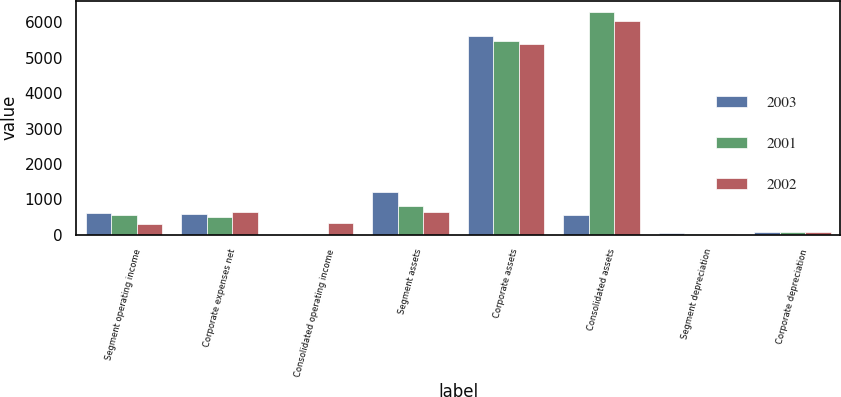<chart> <loc_0><loc_0><loc_500><loc_500><stacked_bar_chart><ecel><fcel>Segment operating income<fcel>Corporate expenses net<fcel>Consolidated operating income<fcel>Segment assets<fcel>Corporate assets<fcel>Consolidated assets<fcel>Segment depreciation<fcel>Corporate depreciation<nl><fcel>2003<fcel>620<fcel>595<fcel>1<fcel>1197<fcel>5618<fcel>562<fcel>39<fcel>74<nl><fcel>2001<fcel>562<fcel>514<fcel>17<fcel>818<fcel>5480<fcel>6298<fcel>28<fcel>86<nl><fcel>2002<fcel>297<fcel>630<fcel>344<fcel>631<fcel>5390<fcel>6021<fcel>16<fcel>84<nl></chart> 